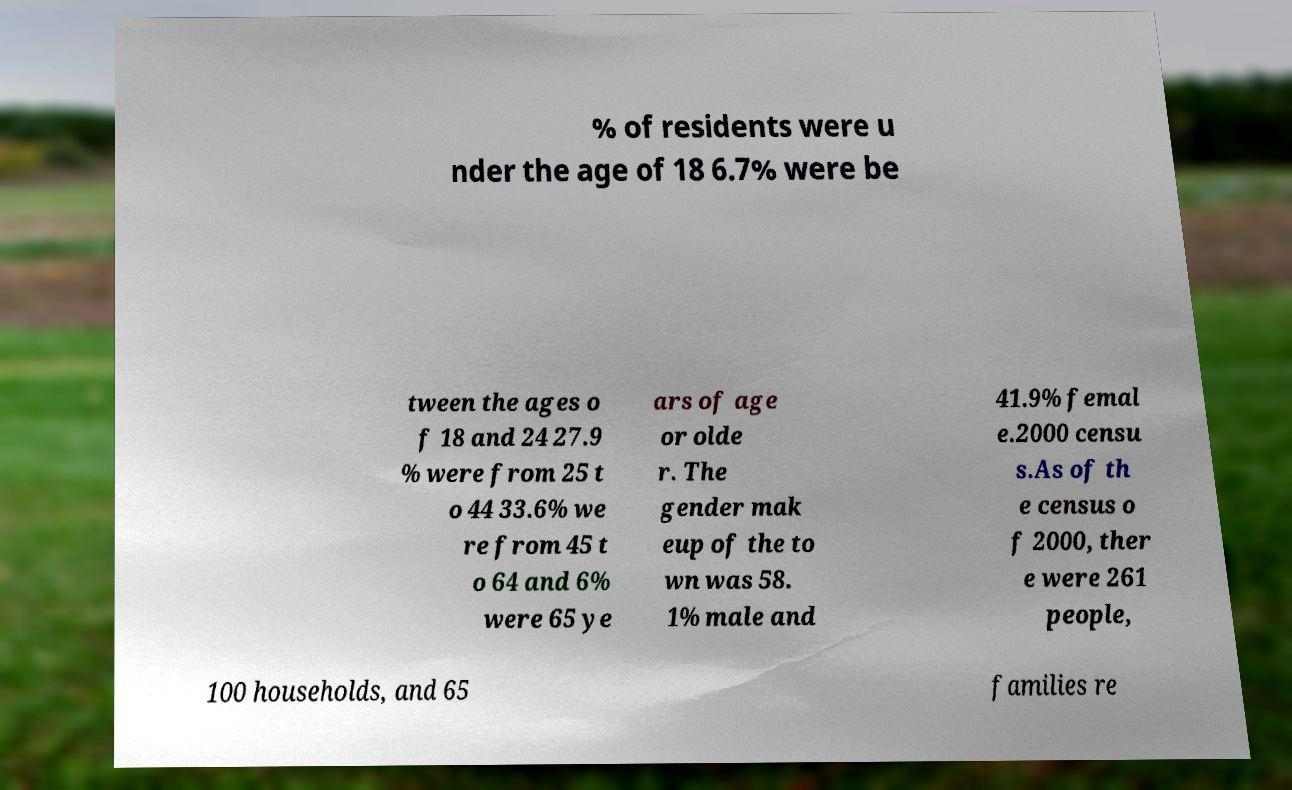For documentation purposes, I need the text within this image transcribed. Could you provide that? % of residents were u nder the age of 18 6.7% were be tween the ages o f 18 and 24 27.9 % were from 25 t o 44 33.6% we re from 45 t o 64 and 6% were 65 ye ars of age or olde r. The gender mak eup of the to wn was 58. 1% male and 41.9% femal e.2000 censu s.As of th e census o f 2000, ther e were 261 people, 100 households, and 65 families re 